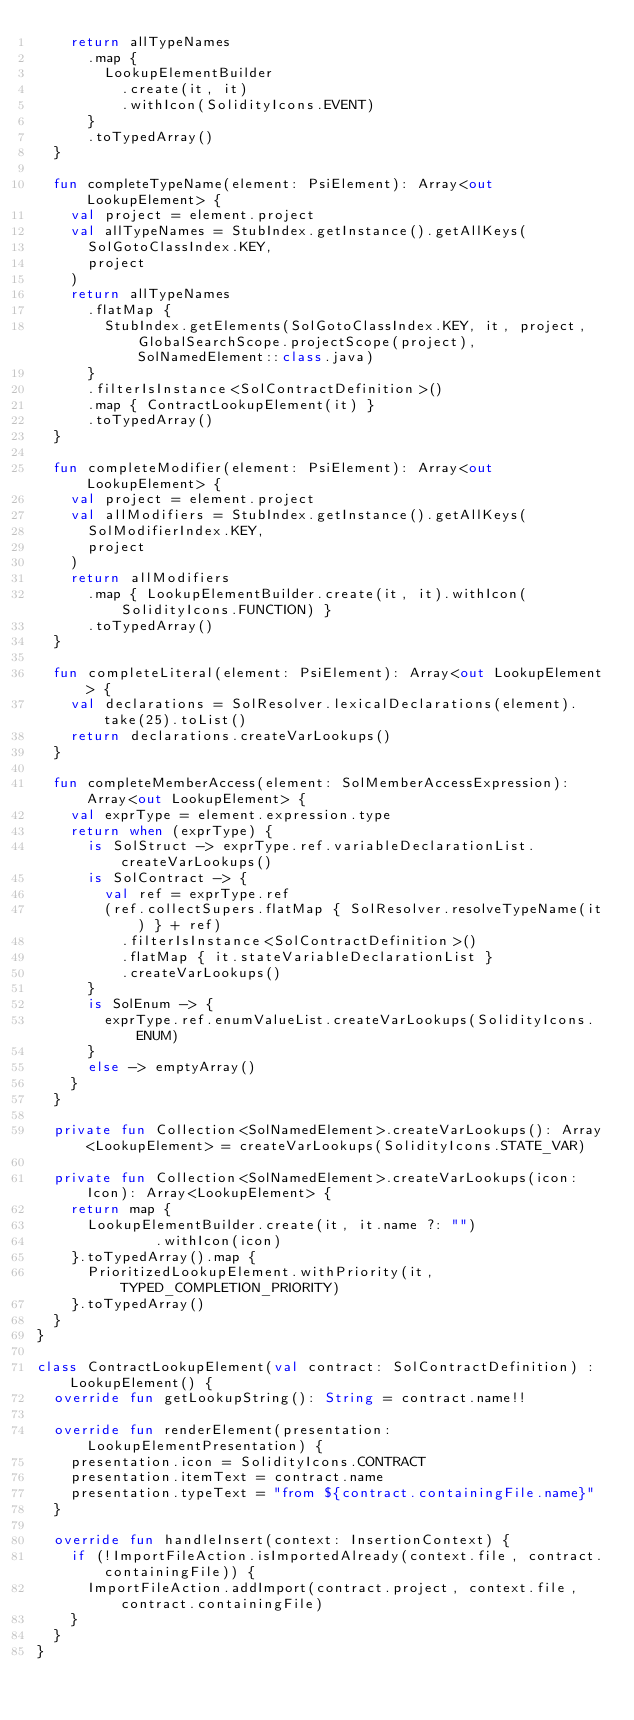Convert code to text. <code><loc_0><loc_0><loc_500><loc_500><_Kotlin_>    return allTypeNames
      .map {
        LookupElementBuilder
          .create(it, it)
          .withIcon(SolidityIcons.EVENT)
      }
      .toTypedArray()
  }

  fun completeTypeName(element: PsiElement): Array<out LookupElement> {
    val project = element.project
    val allTypeNames = StubIndex.getInstance().getAllKeys(
      SolGotoClassIndex.KEY,
      project
    )
    return allTypeNames
      .flatMap {
        StubIndex.getElements(SolGotoClassIndex.KEY, it, project, GlobalSearchScope.projectScope(project), SolNamedElement::class.java)
      }
      .filterIsInstance<SolContractDefinition>()
      .map { ContractLookupElement(it) }
      .toTypedArray()
  }

  fun completeModifier(element: PsiElement): Array<out LookupElement> {
    val project = element.project
    val allModifiers = StubIndex.getInstance().getAllKeys(
      SolModifierIndex.KEY,
      project
    )
    return allModifiers
      .map { LookupElementBuilder.create(it, it).withIcon(SolidityIcons.FUNCTION) }
      .toTypedArray()
  }

  fun completeLiteral(element: PsiElement): Array<out LookupElement> {
    val declarations = SolResolver.lexicalDeclarations(element).take(25).toList()
    return declarations.createVarLookups()
  }

  fun completeMemberAccess(element: SolMemberAccessExpression): Array<out LookupElement> {
    val exprType = element.expression.type
    return when (exprType) {
      is SolStruct -> exprType.ref.variableDeclarationList.createVarLookups()
      is SolContract -> {
        val ref = exprType.ref
        (ref.collectSupers.flatMap { SolResolver.resolveTypeName(it) } + ref)
          .filterIsInstance<SolContractDefinition>()
          .flatMap { it.stateVariableDeclarationList }
          .createVarLookups()
      }
      is SolEnum -> {
        exprType.ref.enumValueList.createVarLookups(SolidityIcons.ENUM)
      }
      else -> emptyArray()
    }
  }

  private fun Collection<SolNamedElement>.createVarLookups(): Array<LookupElement> = createVarLookups(SolidityIcons.STATE_VAR)

  private fun Collection<SolNamedElement>.createVarLookups(icon: Icon): Array<LookupElement> {
    return map {
      LookupElementBuilder.create(it, it.name ?: "")
              .withIcon(icon)
    }.toTypedArray().map {
      PrioritizedLookupElement.withPriority(it, TYPED_COMPLETION_PRIORITY)
    }.toTypedArray()
  }
}

class ContractLookupElement(val contract: SolContractDefinition) : LookupElement() {
  override fun getLookupString(): String = contract.name!!

  override fun renderElement(presentation: LookupElementPresentation) {
    presentation.icon = SolidityIcons.CONTRACT
    presentation.itemText = contract.name
    presentation.typeText = "from ${contract.containingFile.name}"
  }

  override fun handleInsert(context: InsertionContext) {
    if (!ImportFileAction.isImportedAlready(context.file, contract.containingFile)) {
      ImportFileAction.addImport(contract.project, context.file, contract.containingFile)
    }
  }
}
</code> 